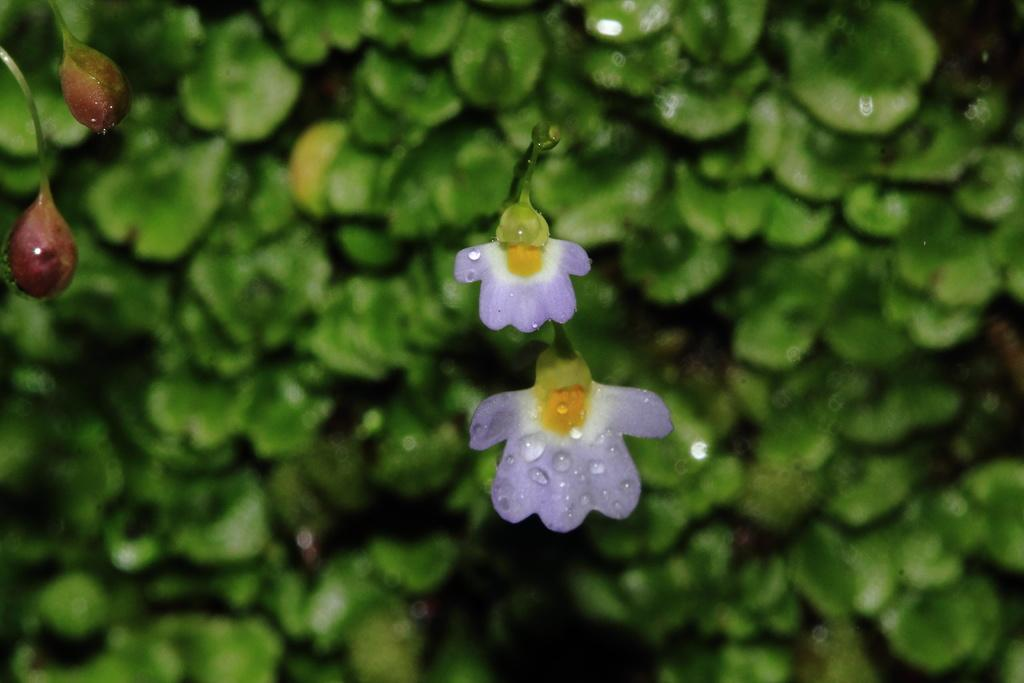What type of plants can be seen in the image? There are flowers in the image. What stage of growth can be observed on the trees in the image? There are buds on trees in the image. Can you see any insects interacting with the flowers in the image? There is no insect present in the image. What type of test can be performed on the buds of the trees in the image? The facts provided do not mention any tests related to the buds on the trees. Is there any indication of a kiss being shared between the flowers in the image? There is no indication of a kiss being shared between the flowers in the image. 